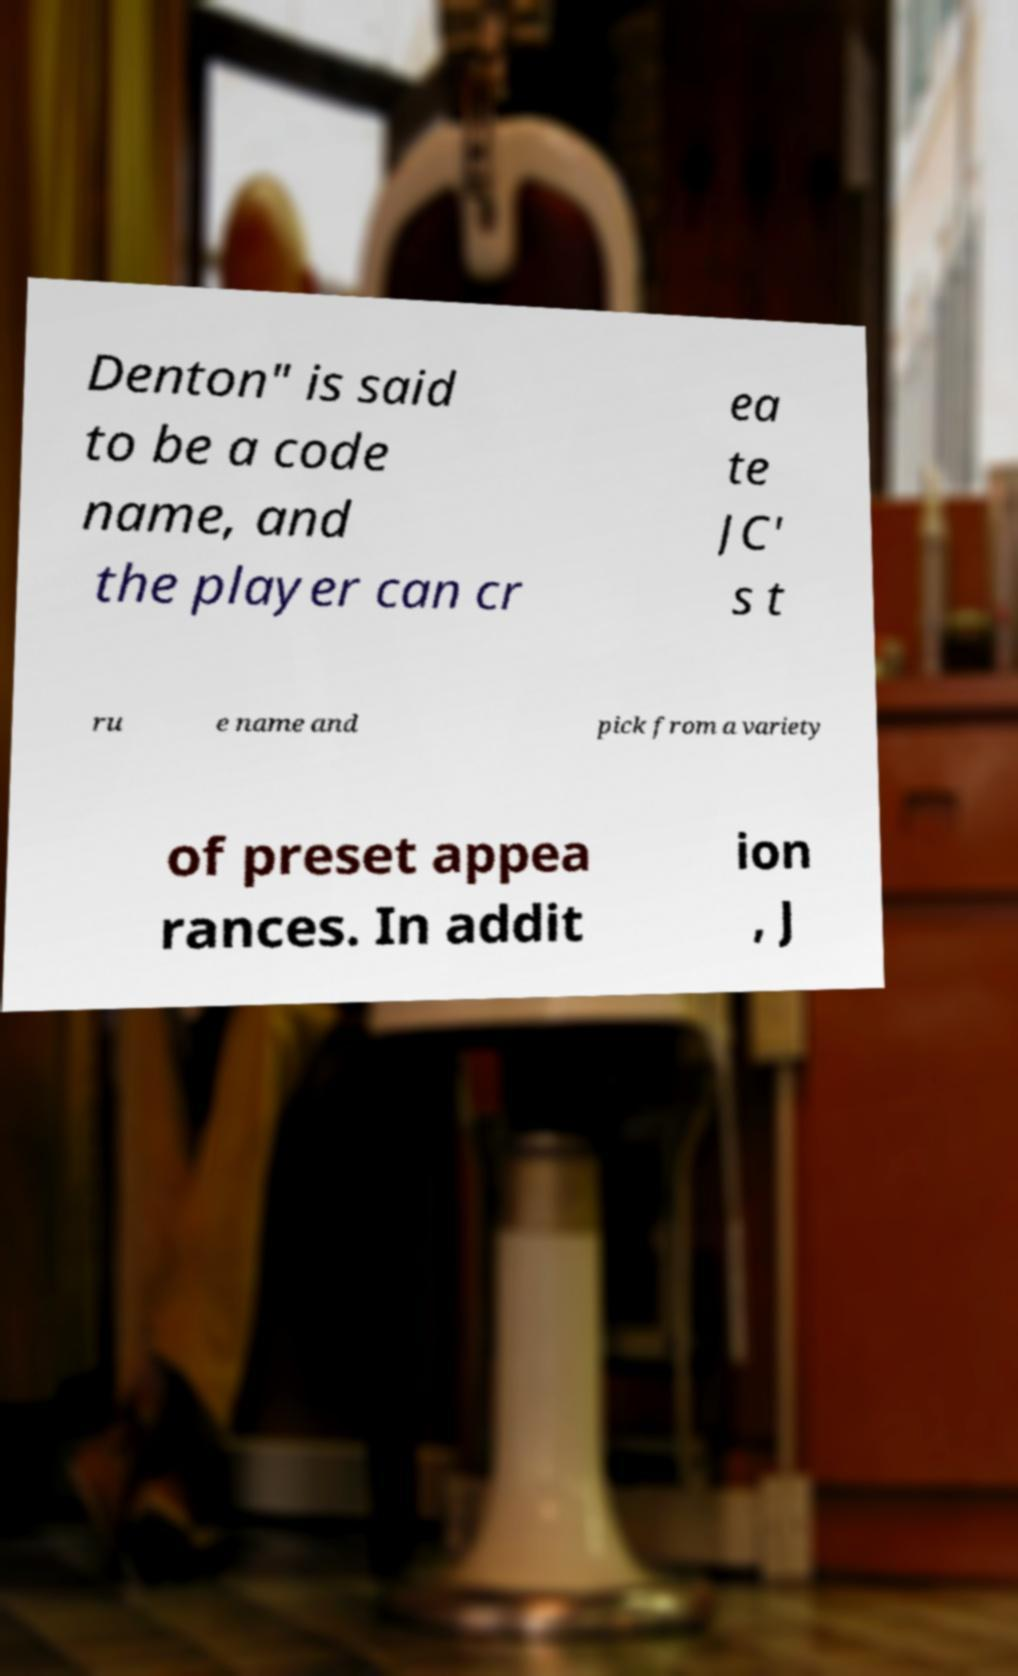What messages or text are displayed in this image? I need them in a readable, typed format. Denton" is said to be a code name, and the player can cr ea te JC' s t ru e name and pick from a variety of preset appea rances. In addit ion , J 